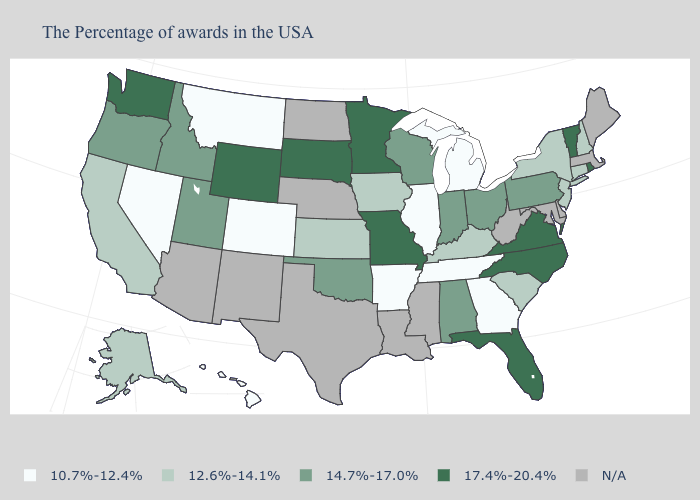Which states have the lowest value in the USA?
Quick response, please. Georgia, Michigan, Tennessee, Illinois, Arkansas, Colorado, Montana, Nevada, Hawaii. What is the highest value in the USA?
Concise answer only. 17.4%-20.4%. What is the value of Hawaii?
Give a very brief answer. 10.7%-12.4%. Does the map have missing data?
Give a very brief answer. Yes. What is the lowest value in states that border Pennsylvania?
Write a very short answer. 12.6%-14.1%. Name the states that have a value in the range 10.7%-12.4%?
Quick response, please. Georgia, Michigan, Tennessee, Illinois, Arkansas, Colorado, Montana, Nevada, Hawaii. Does Colorado have the lowest value in the USA?
Keep it brief. Yes. What is the value of Minnesota?
Short answer required. 17.4%-20.4%. Name the states that have a value in the range 12.6%-14.1%?
Be succinct. New Hampshire, Connecticut, New York, New Jersey, South Carolina, Kentucky, Iowa, Kansas, California, Alaska. What is the value of South Carolina?
Give a very brief answer. 12.6%-14.1%. Is the legend a continuous bar?
Concise answer only. No. What is the value of South Carolina?
Give a very brief answer. 12.6%-14.1%. Which states have the highest value in the USA?
Answer briefly. Rhode Island, Vermont, Virginia, North Carolina, Florida, Missouri, Minnesota, South Dakota, Wyoming, Washington. Does New Jersey have the lowest value in the USA?
Give a very brief answer. No. 